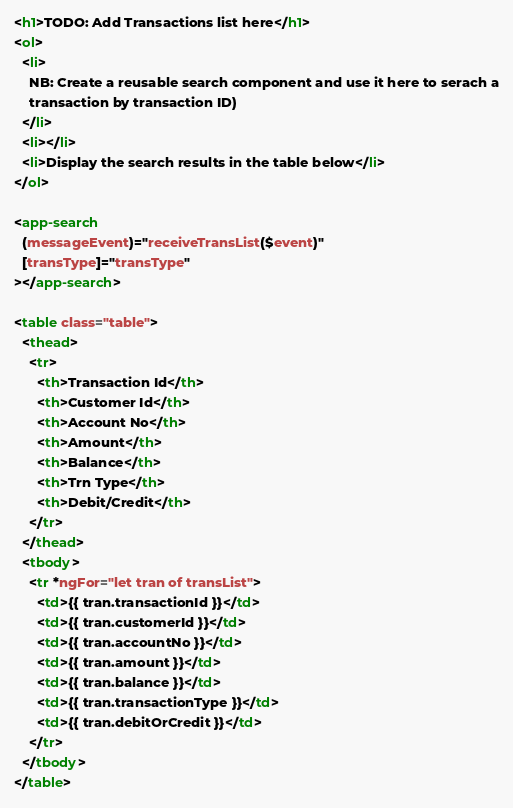Convert code to text. <code><loc_0><loc_0><loc_500><loc_500><_HTML_><h1>TODO: Add Transactions list here</h1>
<ol>
  <li>
    NB: Create a reusable search component and use it here to serach a
    transaction by transaction ID)
  </li>
  <li></li>
  <li>Display the search results in the table below</li>
</ol>

<app-search
  (messageEvent)="receiveTransList($event)"
  [transType]="transType"
></app-search>

<table class="table">
  <thead>
    <tr>
      <th>Transaction Id</th>
      <th>Customer Id</th>
      <th>Account No</th>
      <th>Amount</th>
      <th>Balance</th>
      <th>Trn Type</th>
      <th>Debit/Credit</th>
    </tr>
  </thead>
  <tbody>
    <tr *ngFor="let tran of transList">
      <td>{{ tran.transactionId }}</td>
      <td>{{ tran.customerId }}</td>
      <td>{{ tran.accountNo }}</td>
      <td>{{ tran.amount }}</td>
      <td>{{ tran.balance }}</td>
      <td>{{ tran.transactionType }}</td>
      <td>{{ tran.debitOrCredit }}</td>
    </tr>
  </tbody>
</table>
</code> 